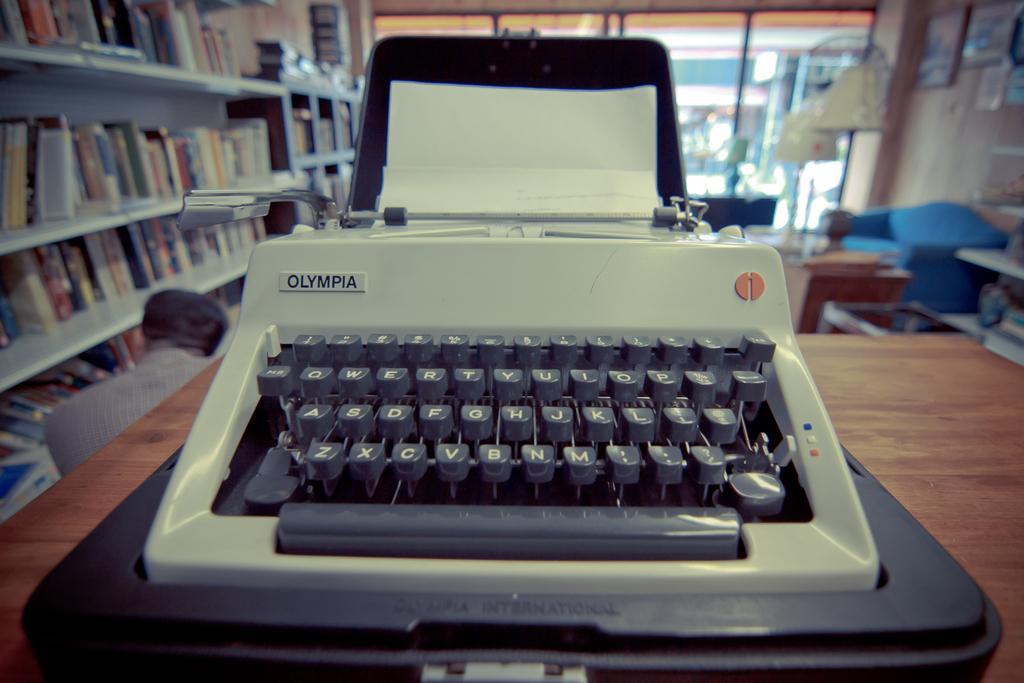Please provide a concise description of this image. In the image we can see a typewriter, these are the keywords and the typewriter is kept on the wooden surface. We can even see there are many books in the shelf. This is a glass window and there is a person wearing clothes. 